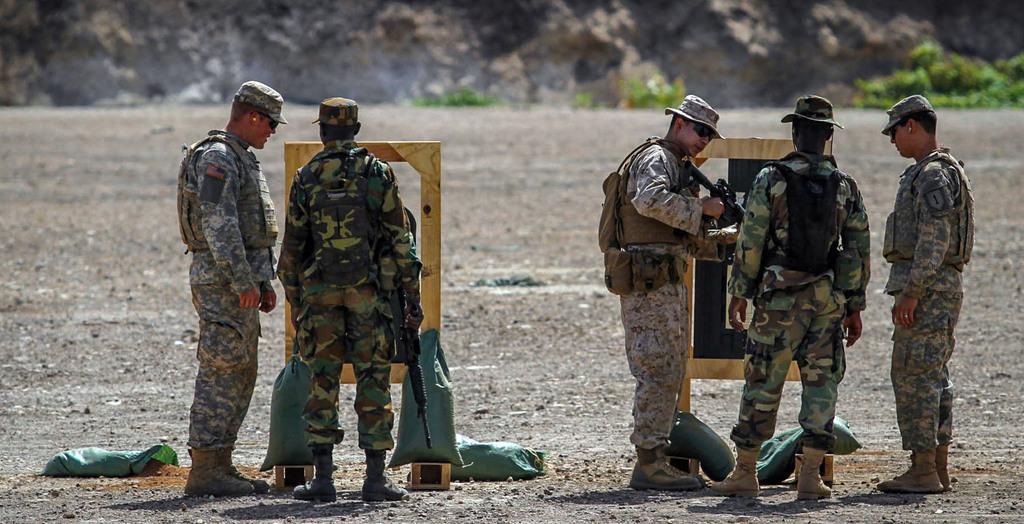In one or two sentences, can you explain what this image depicts? In this picture I can see there are five people standing here and they are wearing a uniform and they are holding guns and there is a mountain in the backdrop. 